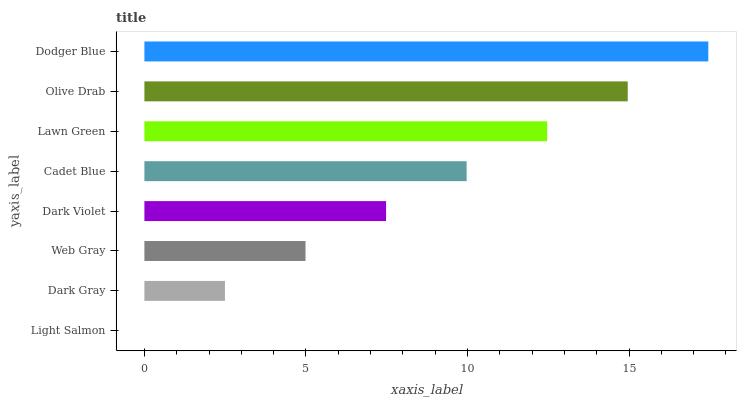Is Light Salmon the minimum?
Answer yes or no. Yes. Is Dodger Blue the maximum?
Answer yes or no. Yes. Is Dark Gray the minimum?
Answer yes or no. No. Is Dark Gray the maximum?
Answer yes or no. No. Is Dark Gray greater than Light Salmon?
Answer yes or no. Yes. Is Light Salmon less than Dark Gray?
Answer yes or no. Yes. Is Light Salmon greater than Dark Gray?
Answer yes or no. No. Is Dark Gray less than Light Salmon?
Answer yes or no. No. Is Cadet Blue the high median?
Answer yes or no. Yes. Is Dark Violet the low median?
Answer yes or no. Yes. Is Dark Gray the high median?
Answer yes or no. No. Is Lawn Green the low median?
Answer yes or no. No. 